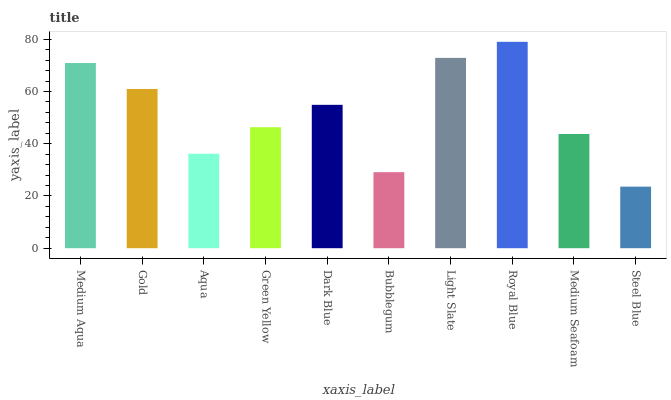Is Steel Blue the minimum?
Answer yes or no. Yes. Is Royal Blue the maximum?
Answer yes or no. Yes. Is Gold the minimum?
Answer yes or no. No. Is Gold the maximum?
Answer yes or no. No. Is Medium Aqua greater than Gold?
Answer yes or no. Yes. Is Gold less than Medium Aqua?
Answer yes or no. Yes. Is Gold greater than Medium Aqua?
Answer yes or no. No. Is Medium Aqua less than Gold?
Answer yes or no. No. Is Dark Blue the high median?
Answer yes or no. Yes. Is Green Yellow the low median?
Answer yes or no. Yes. Is Green Yellow the high median?
Answer yes or no. No. Is Bubblegum the low median?
Answer yes or no. No. 